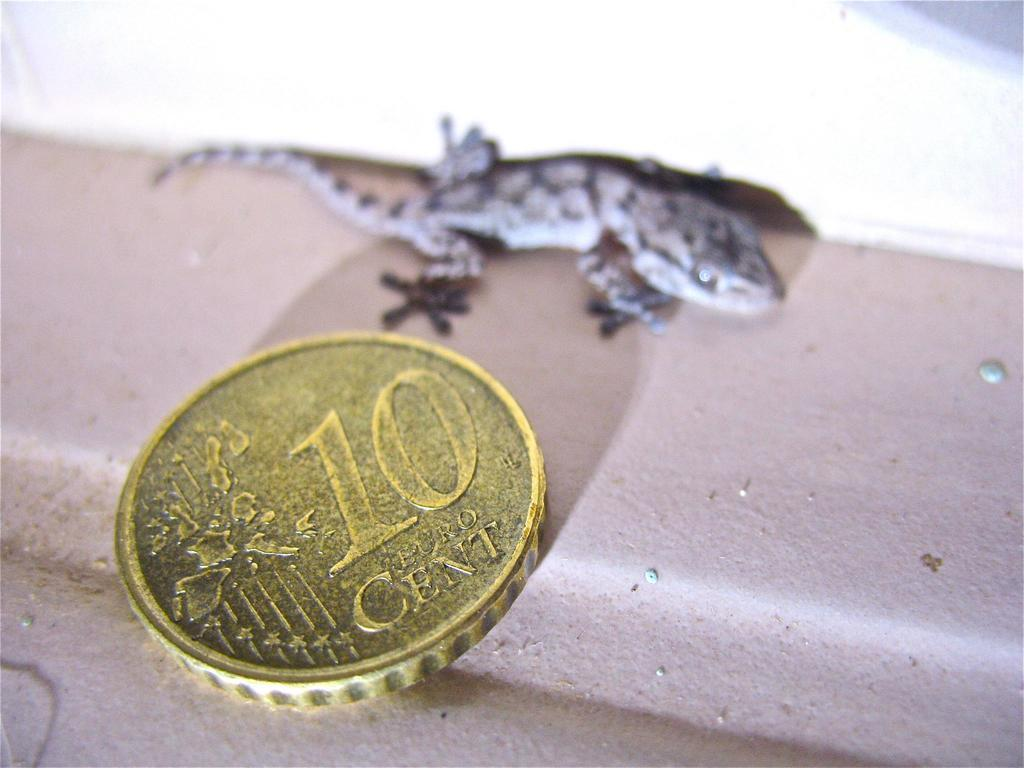What type of animal is in the image? There is a lizard in the image. What other object is present in the image? There is a coin in the image. Where are the lizard and the coin located? Both the lizard and the coin are on a surface. What is the title of the book that the lizard is reading in the image? There is no book or reading activity depicted in the image; it features a lizard and a coin on a surface. 